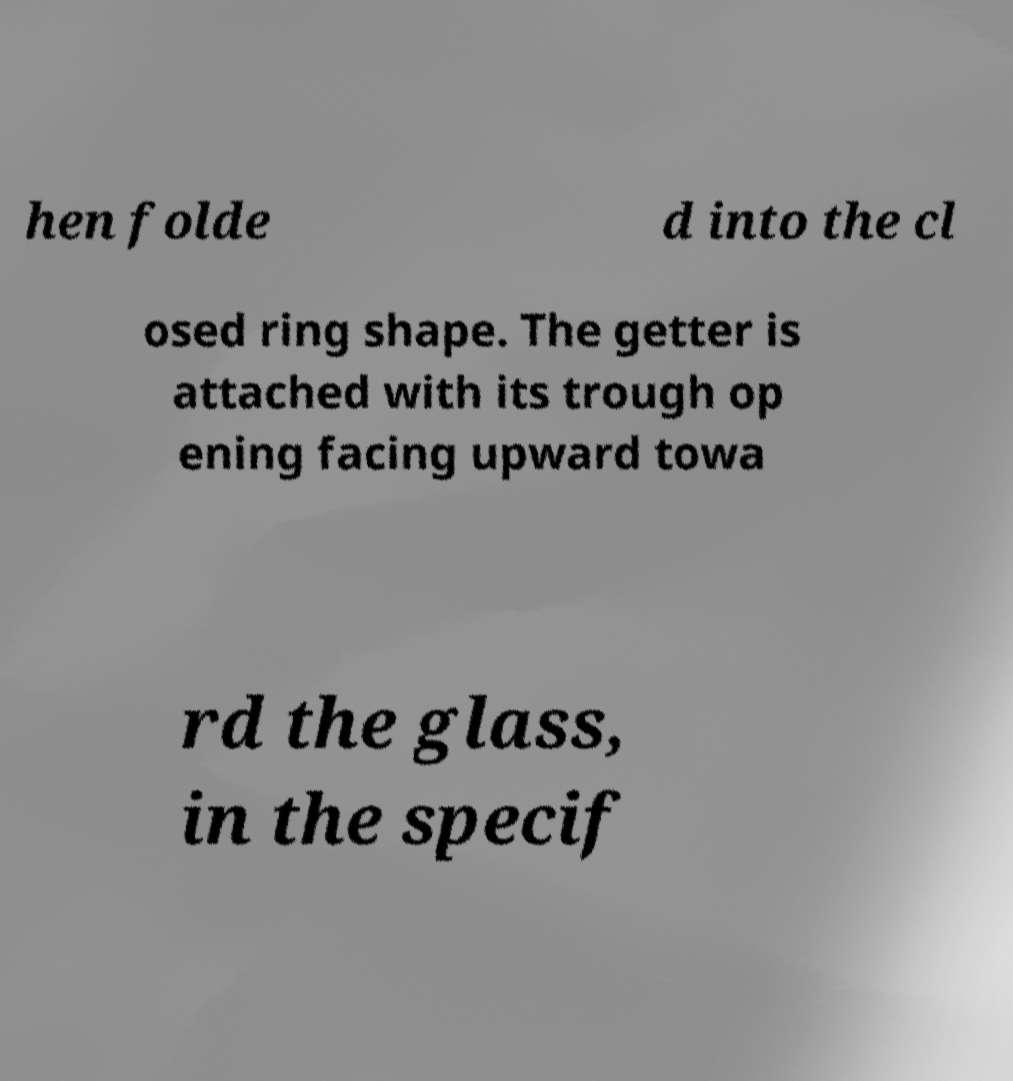There's text embedded in this image that I need extracted. Can you transcribe it verbatim? hen folde d into the cl osed ring shape. The getter is attached with its trough op ening facing upward towa rd the glass, in the specif 